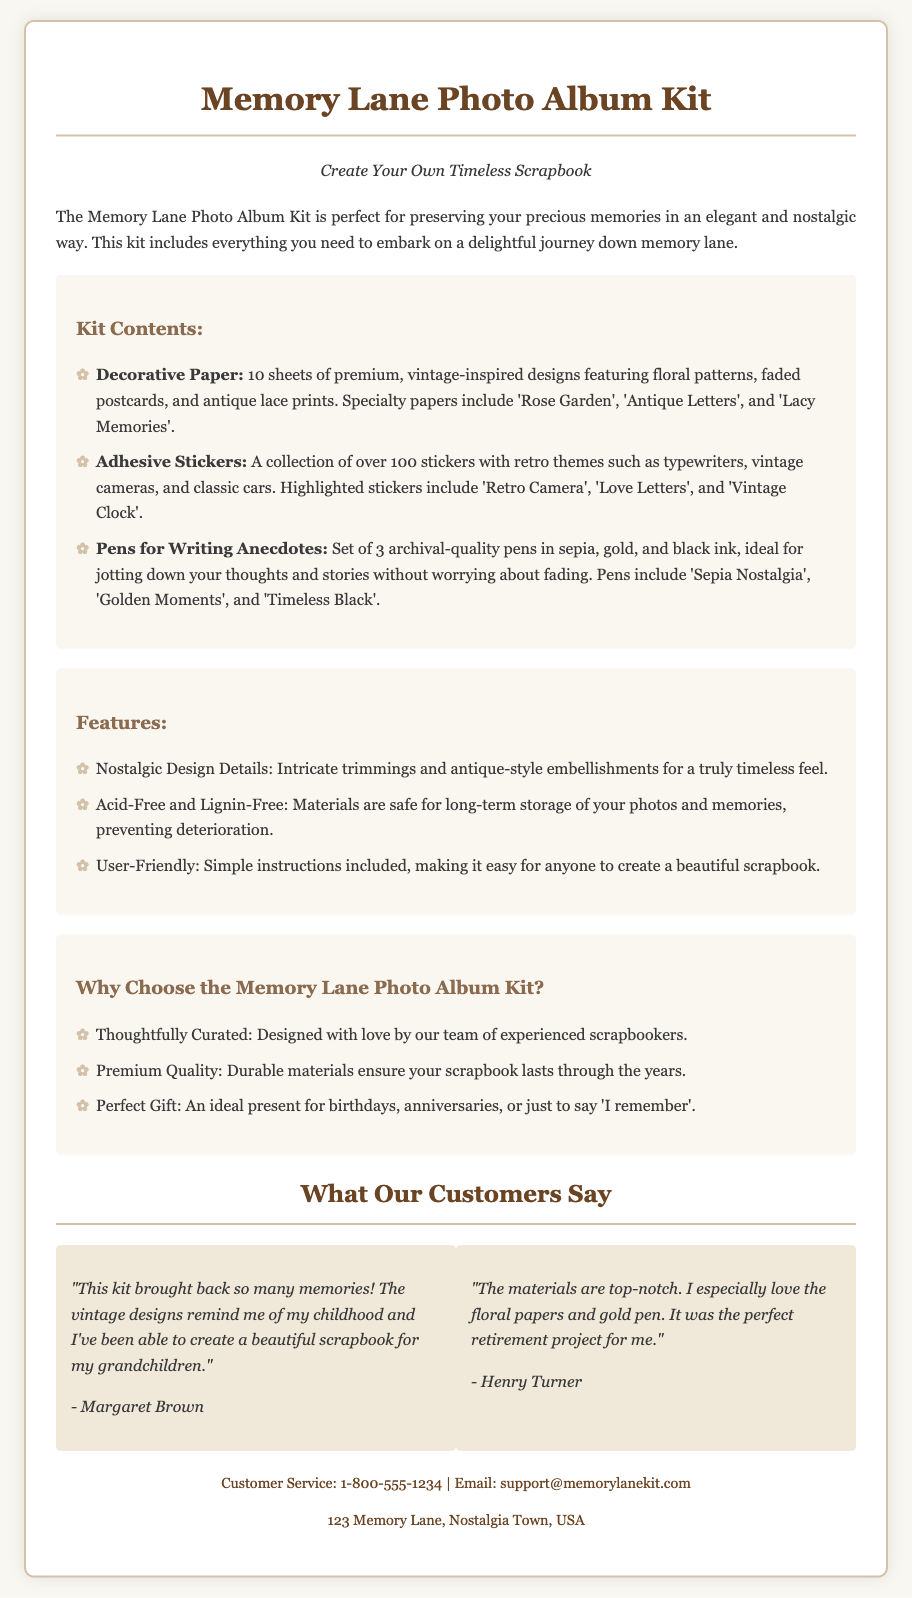What is the name of the product? The product is referred to as the "Memory Lane Photo Album Kit" in the document.
Answer: Memory Lane Photo Album Kit How many sheets of decorative paper are included? The document states that there are 10 sheets of decorative paper included in the kit.
Answer: 10 sheets What themes are featured in the adhesive stickers? The themes mentioned for the adhesive stickers include retro themes such as typewriters, vintage cameras, and classic cars.
Answer: Retro themes What are the colors of the pens included in the kit? The document mentions three colors of the pens: sepia, gold, and black.
Answer: Sepia, gold, black Why is the material described as acid-free? The materials are stated to be acid-free and lignin-free to ensure safe long-term storage of photos and memories, preventing deterioration.
Answer: Safe long-term storage What is highlighted as an ideal gift occasion for the scrapbook kit? The document specifies that it is an ideal present for birthdays and anniversaries, among other occasions.
Answer: Birthdays, anniversaries Who designed the kit? The document indicates that the kit was designed by a team of experienced scrapbookers.
Answer: Experienced scrapbookers What is the primary customer feedback about the kit? Customer testimonials highlight that the kit brings back memories and allows for beautiful scrapbook creation.
Answer: Brings back memories 